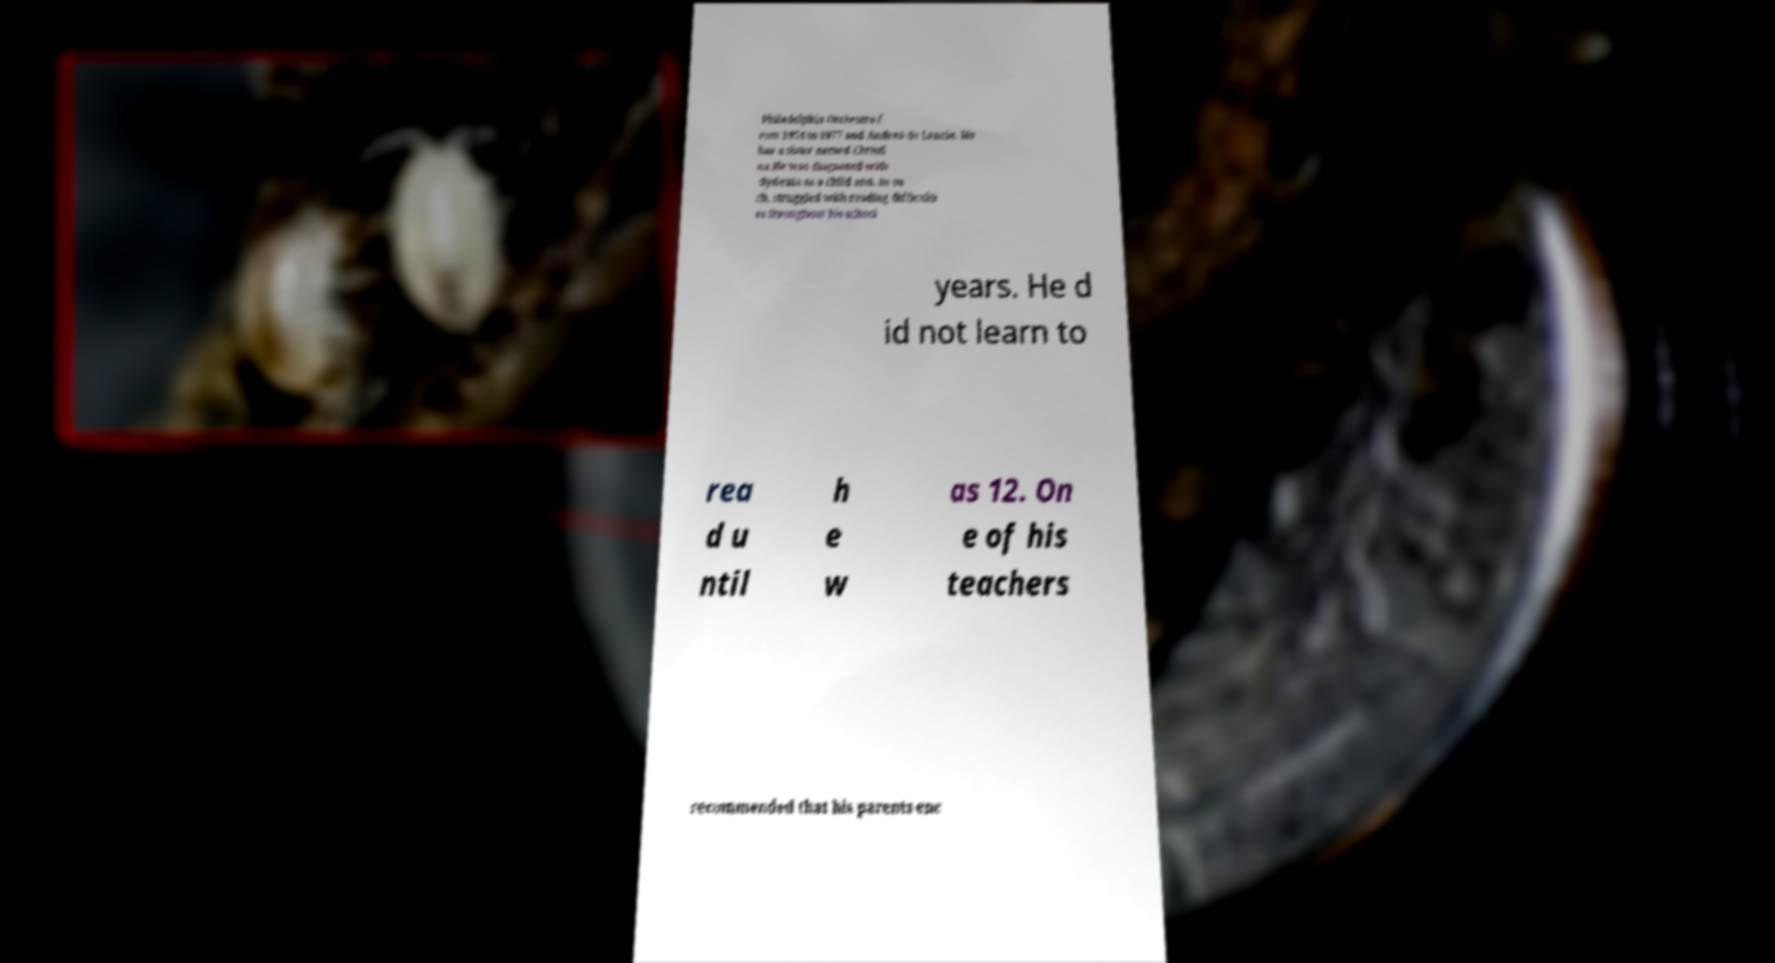I need the written content from this picture converted into text. Can you do that? Philadelphia Orchestra f rom 1954 to 1977 and Andrea de Lancie. He has a sister named Christi na.He was diagnosed with dyslexia as a child and, as su ch, struggled with reading difficulti es throughout his school years. He d id not learn to rea d u ntil h e w as 12. On e of his teachers recommended that his parents enc 